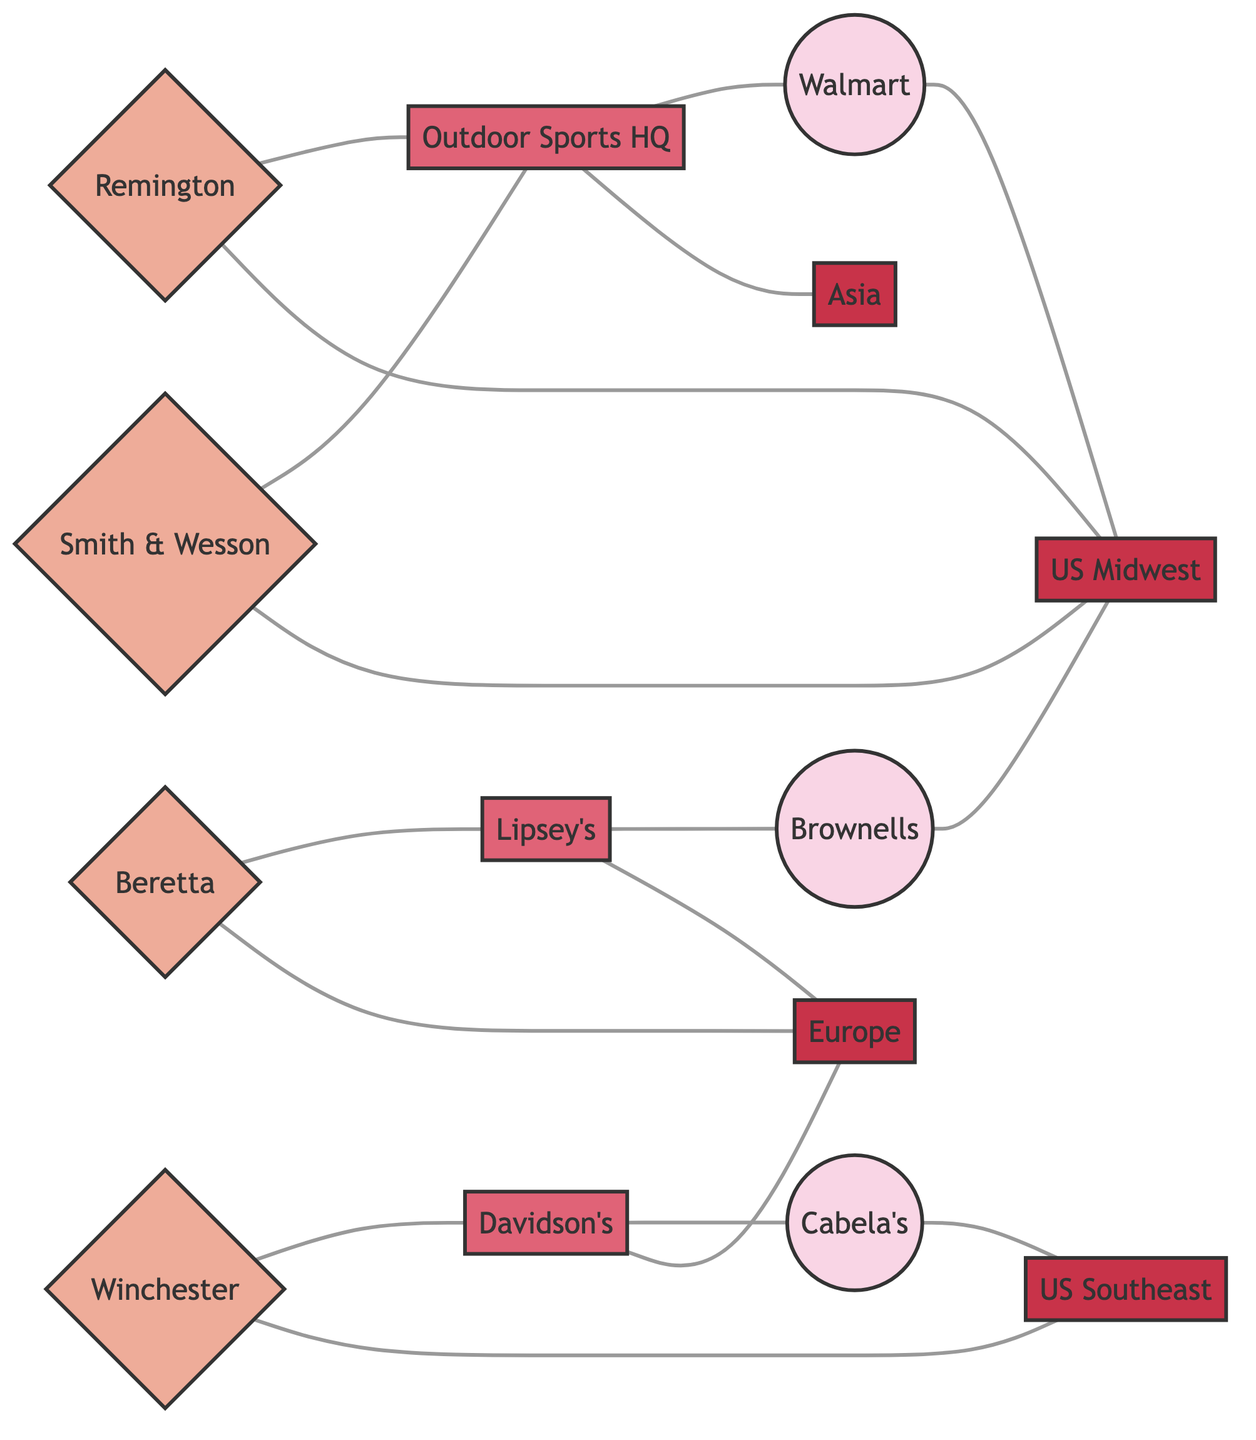What is the total number of nodes in the diagram? By counting each unique node listed in the diagram, we find 13 nodes in total: 4 manufacturers, 3 distributors, 3 retailers, and 3 regions.
Answer: 13 Which retailer is connected to Outdoor Sports Headquarters? In the diagram, Walmart is connected to Outdoor Sports Headquarters as a distribution link.
Answer: Walmart How many manufacturers operate in the US Midwest region? By examining the edges, we see that Remington and Smith & Wesson both are connected to the US Midwest, indicating they operate in that region. This gives us 2 manufacturers.
Answer: 2 Which distributor exports firearms to Europe? The diagram shows that both Davidson's and Lipsey's export firearms to Europe, which means there are two distributors fulfilling this role.
Answer: Davidson's, Lipsey's How many retailers are connected to the US Southeast region? Cabela's is the only retailer connected directly to the US Southeast through a distribution link, leading to the conclusion that there is 1 retailer connected to this region.
Answer: 1 What relationship connects Winchester to Cabela's? The connection between Winchester and Cabela's is characterized as a distribution link originating from Davidson's, which connects both entities indirectly.
Answer: Distribution Which region is Beretta primarily associated with? In the diagram, Beretta has a direct connection to Europe, indicating that it primarily operates in that region.
Answer: Europe What type of connection exists between Lipsey's and Brownells? The connection between Lipsey's and Brownells is established as a distribution link, demonstrating the flow from distributor to retailer.
Answer: Distribution How many distributors are connected to manufacturers in total? Remington, Winchester, Beretta, and Smith & Wesson are all connected to distributors, which includes Outdoor Sports Headquarters, Davidson's, and Lipsey's. This totals to 5 unique distributor connections to manufacturers.
Answer: 5 